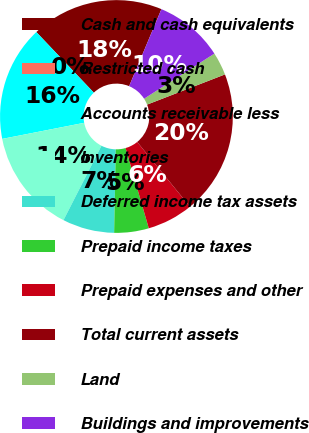<chart> <loc_0><loc_0><loc_500><loc_500><pie_chart><fcel>Cash and cash equivalents<fcel>Restricted cash<fcel>Accounts receivable less<fcel>Inventories<fcel>Deferred income tax assets<fcel>Prepaid income taxes<fcel>Prepaid expenses and other<fcel>Total current assets<fcel>Land<fcel>Buildings and improvements<nl><fcel>18.4%<fcel>0.0%<fcel>16.0%<fcel>14.4%<fcel>7.2%<fcel>4.8%<fcel>6.4%<fcel>20.0%<fcel>3.2%<fcel>9.6%<nl></chart> 